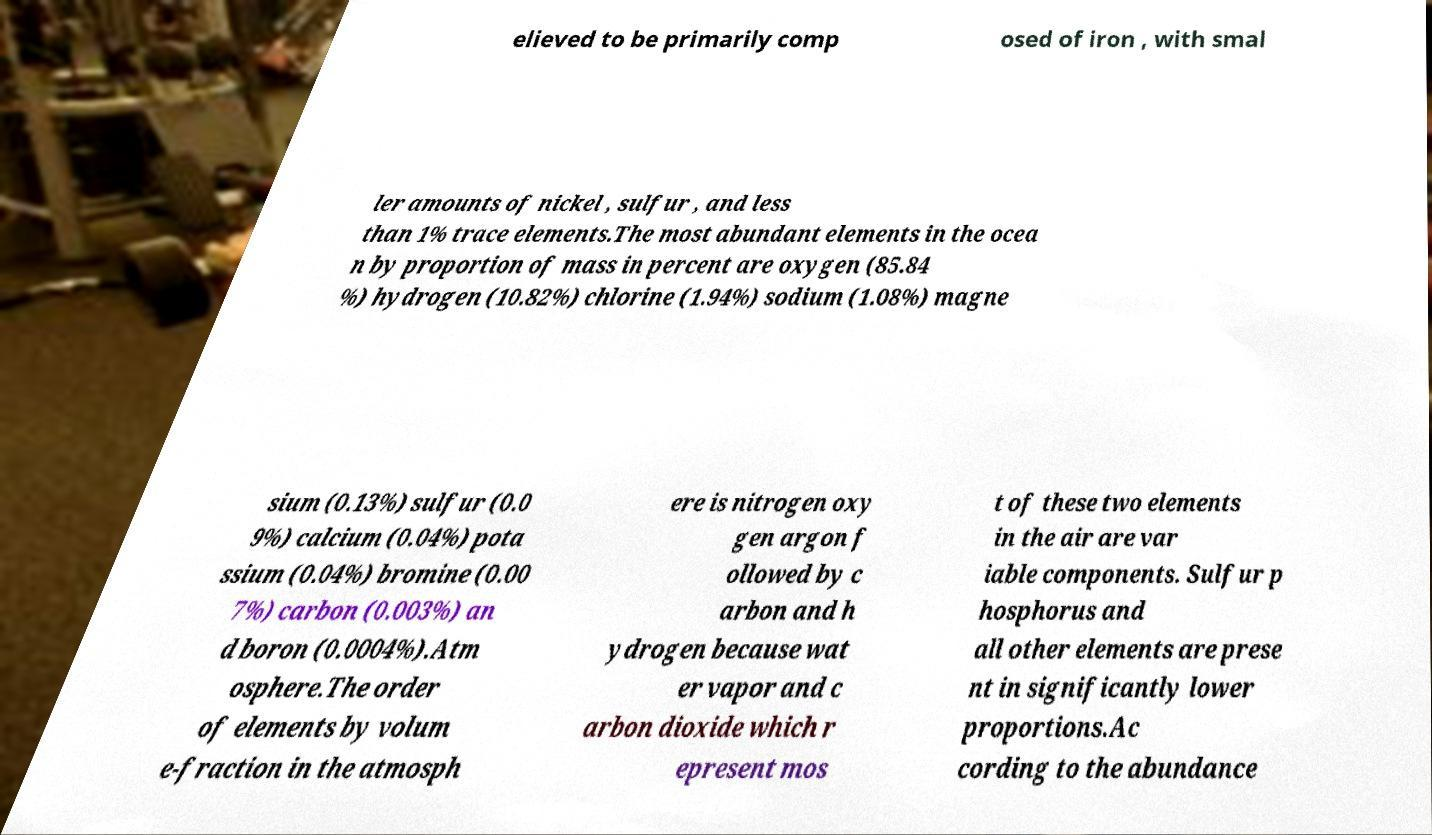Could you assist in decoding the text presented in this image and type it out clearly? elieved to be primarily comp osed of iron , with smal ler amounts of nickel , sulfur , and less than 1% trace elements.The most abundant elements in the ocea n by proportion of mass in percent are oxygen (85.84 %) hydrogen (10.82%) chlorine (1.94%) sodium (1.08%) magne sium (0.13%) sulfur (0.0 9%) calcium (0.04%) pota ssium (0.04%) bromine (0.00 7%) carbon (0.003%) an d boron (0.0004%).Atm osphere.The order of elements by volum e-fraction in the atmosph ere is nitrogen oxy gen argon f ollowed by c arbon and h ydrogen because wat er vapor and c arbon dioxide which r epresent mos t of these two elements in the air are var iable components. Sulfur p hosphorus and all other elements are prese nt in significantly lower proportions.Ac cording to the abundance 